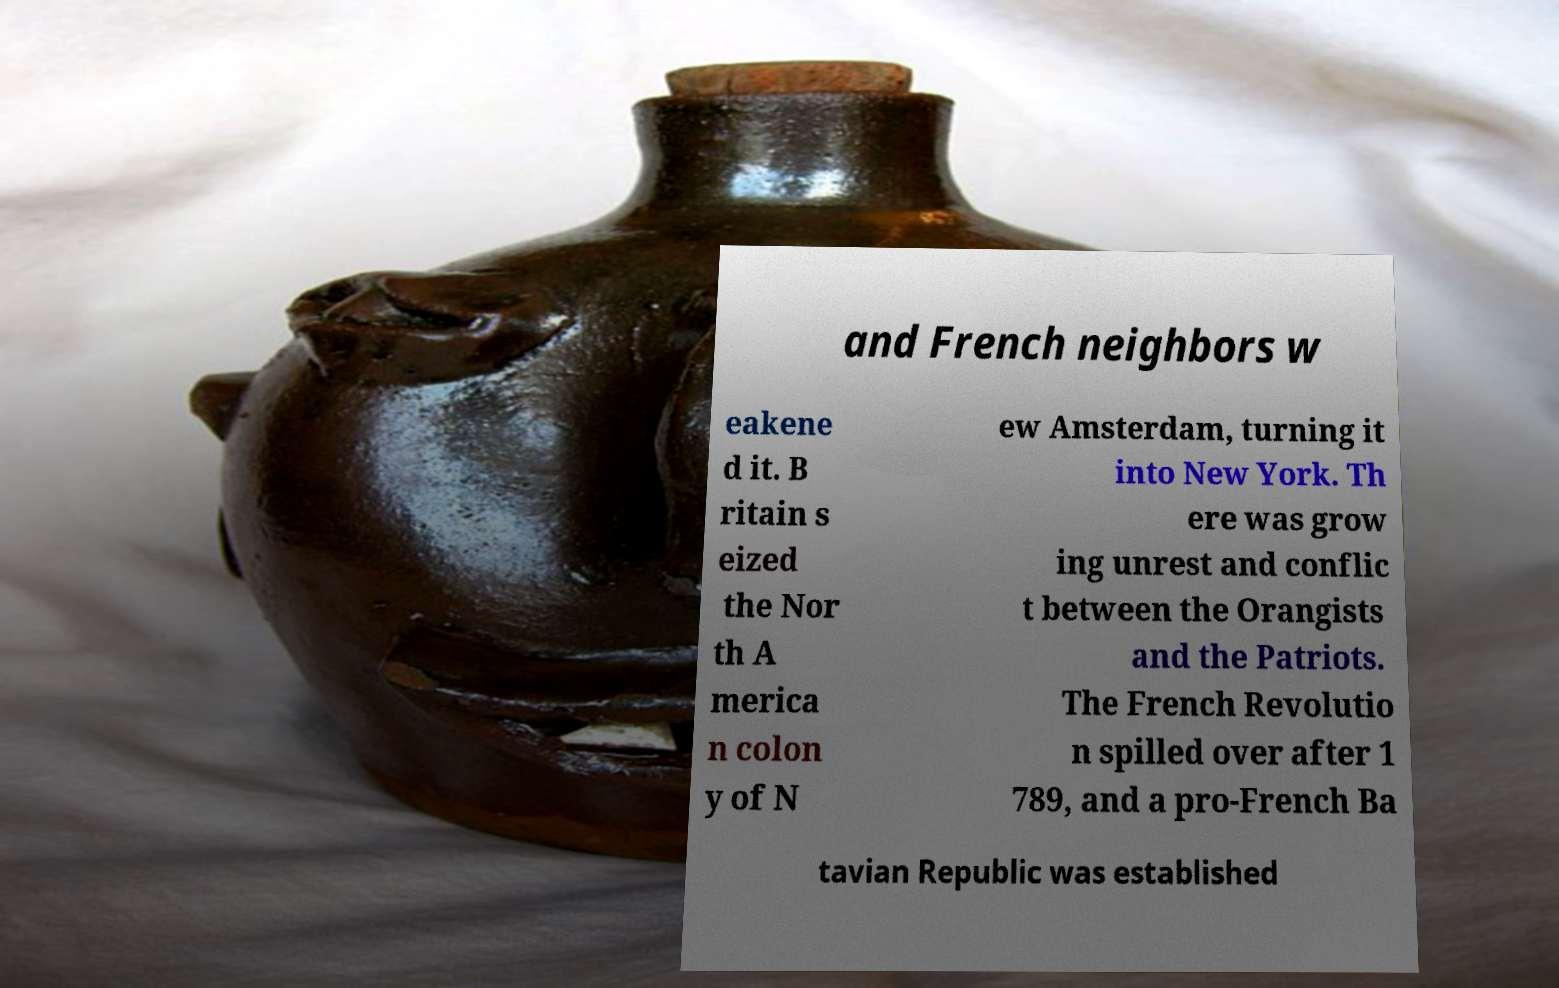There's text embedded in this image that I need extracted. Can you transcribe it verbatim? and French neighbors w eakene d it. B ritain s eized the Nor th A merica n colon y of N ew Amsterdam, turning it into New York. Th ere was grow ing unrest and conflic t between the Orangists and the Patriots. The French Revolutio n spilled over after 1 789, and a pro-French Ba tavian Republic was established 